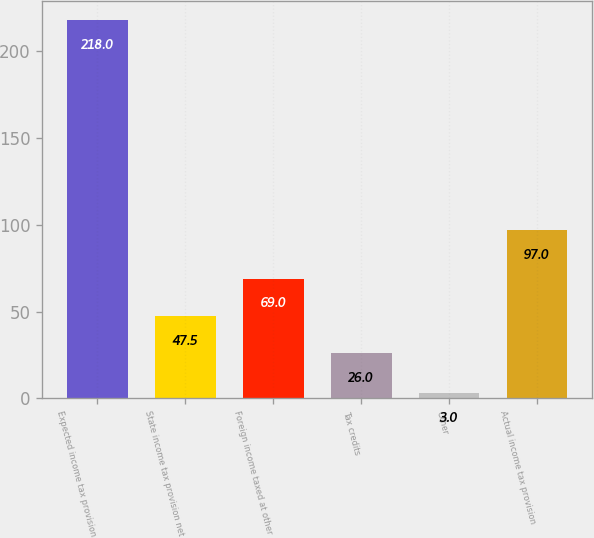Convert chart to OTSL. <chart><loc_0><loc_0><loc_500><loc_500><bar_chart><fcel>Expected income tax provision<fcel>State income tax provision net<fcel>Foreign income taxed at other<fcel>Tax credits<fcel>Other<fcel>Actual income tax provision<nl><fcel>218<fcel>47.5<fcel>69<fcel>26<fcel>3<fcel>97<nl></chart> 